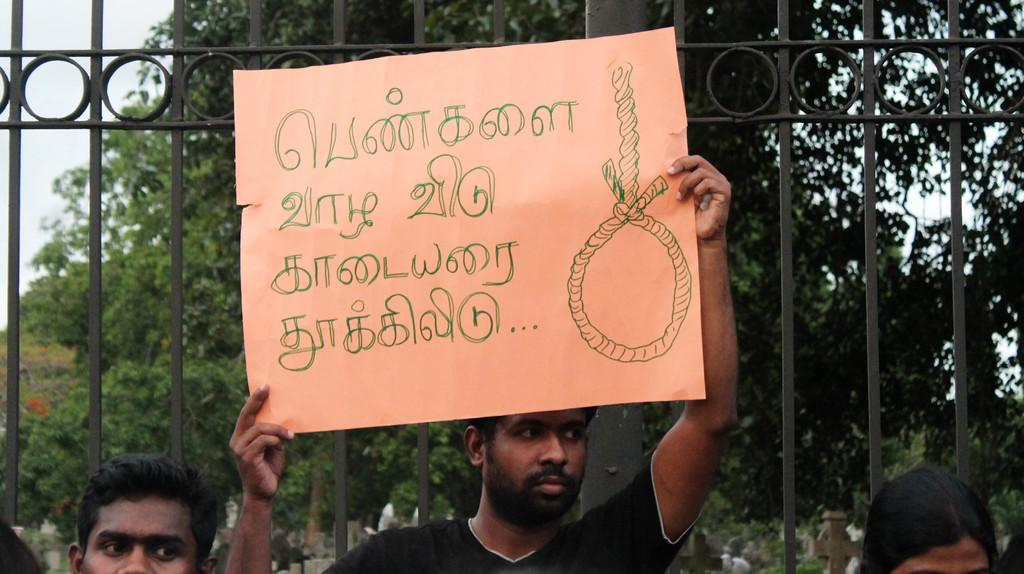What is the person in the image holding? The person is holding a chart in the image. What can be seen on the chart? There is writing on the chart. How many people are in the image? There are people in the image. What type of natural vegetation is visible in the image? There are trees in the image. What is visible in the background of the image? The sky is visible in the image. What type of architectural feature can be seen in the image? There is an iron gate in the image. What type of water feature can be seen in the image? There is no water feature present in the image. 